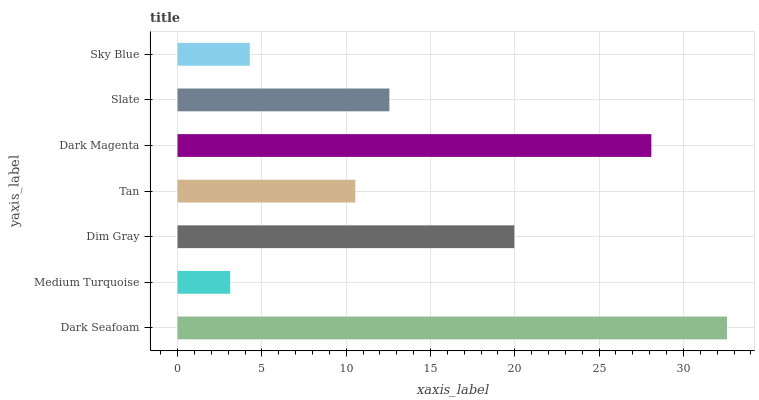Is Medium Turquoise the minimum?
Answer yes or no. Yes. Is Dark Seafoam the maximum?
Answer yes or no. Yes. Is Dim Gray the minimum?
Answer yes or no. No. Is Dim Gray the maximum?
Answer yes or no. No. Is Dim Gray greater than Medium Turquoise?
Answer yes or no. Yes. Is Medium Turquoise less than Dim Gray?
Answer yes or no. Yes. Is Medium Turquoise greater than Dim Gray?
Answer yes or no. No. Is Dim Gray less than Medium Turquoise?
Answer yes or no. No. Is Slate the high median?
Answer yes or no. Yes. Is Slate the low median?
Answer yes or no. Yes. Is Dim Gray the high median?
Answer yes or no. No. Is Dark Seafoam the low median?
Answer yes or no. No. 